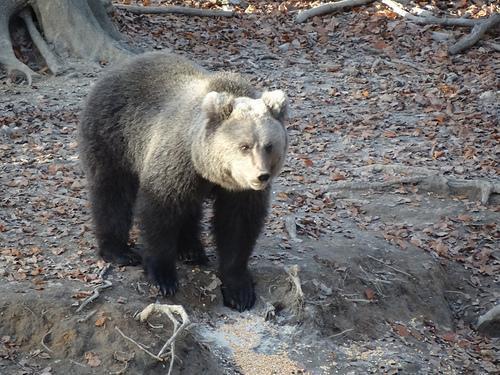How many animals are there?
Give a very brief answer. 1. How many full paws are visible?
Give a very brief answer. 4. 